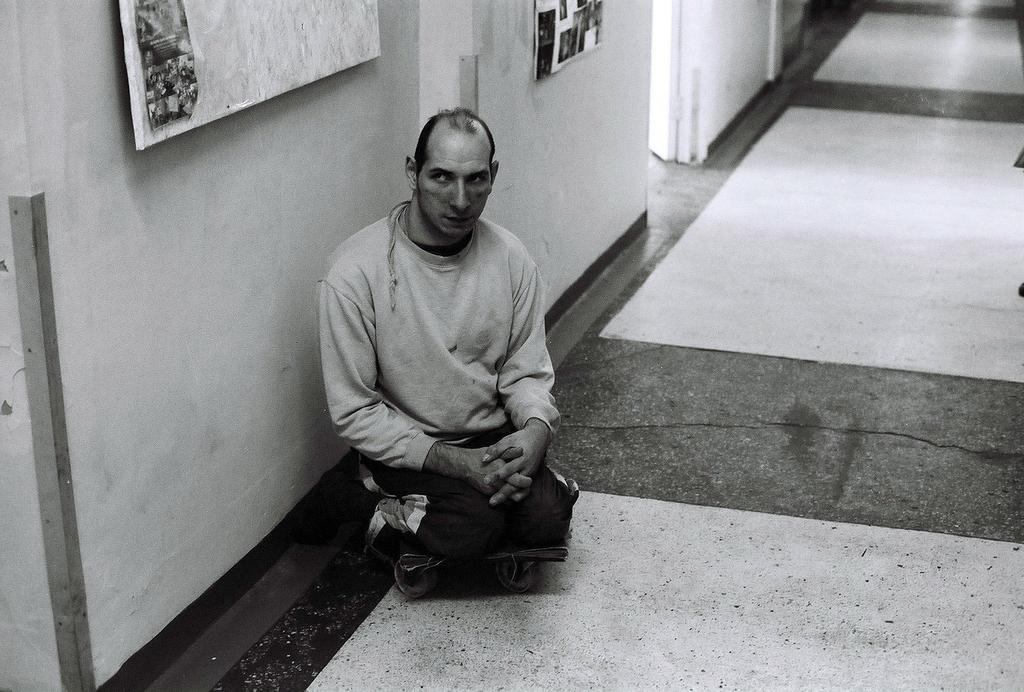What is the person in the image doing? The person is sitting on a trolley in the image. What can be seen in the background of the image? There is a wall in the image. What is attached to the wall? There are two boards on the wall. How is the image presented? The image is in black and white mode. What type of prose is the person reading on the trolley? There is no indication in the image that the person is reading any prose, as the image is in black and white mode and does not show any text. 